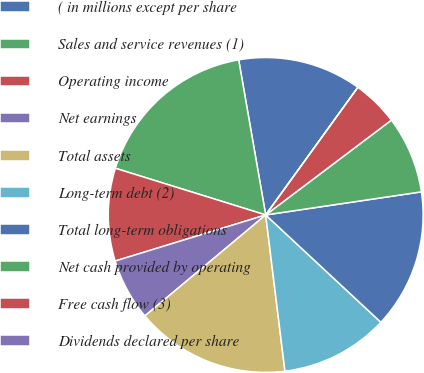<chart> <loc_0><loc_0><loc_500><loc_500><pie_chart><fcel>( in millions except per share<fcel>Sales and service revenues (1)<fcel>Operating income<fcel>Net earnings<fcel>Total assets<fcel>Long-term debt (2)<fcel>Total long-term obligations<fcel>Net cash provided by operating<fcel>Free cash flow (3)<fcel>Dividends declared per share<nl><fcel>12.7%<fcel>17.46%<fcel>9.52%<fcel>6.35%<fcel>15.87%<fcel>11.11%<fcel>14.28%<fcel>7.94%<fcel>4.76%<fcel>0.0%<nl></chart> 